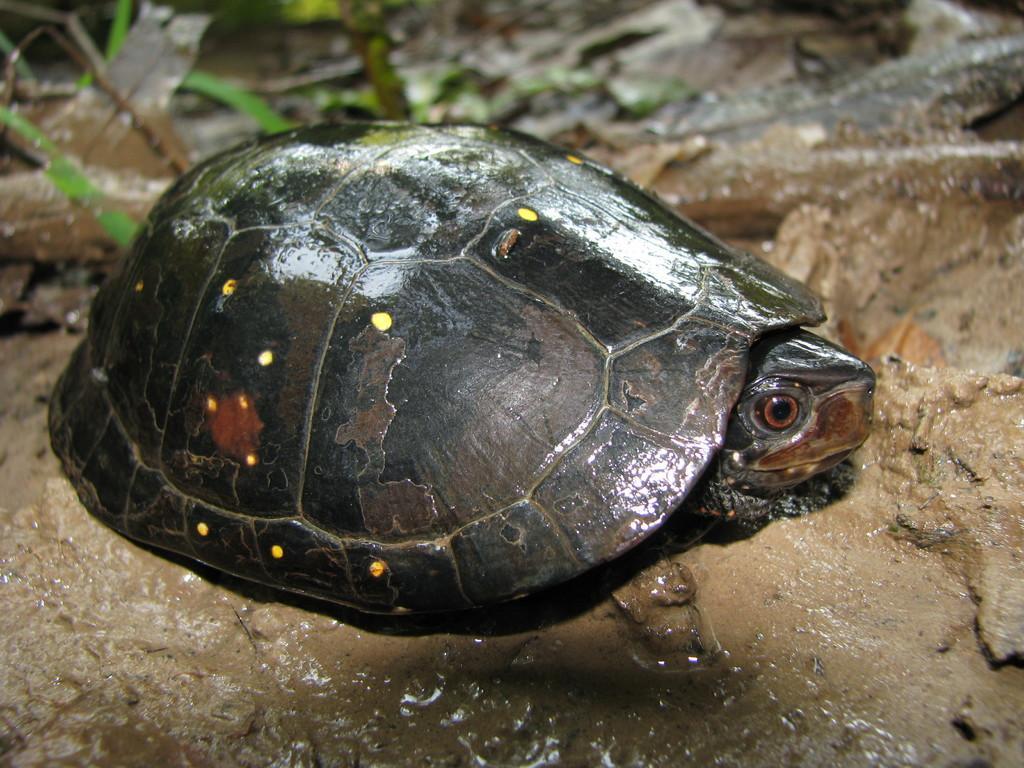Describe this image in one or two sentences. Here we can see a tortoise on the mud. 